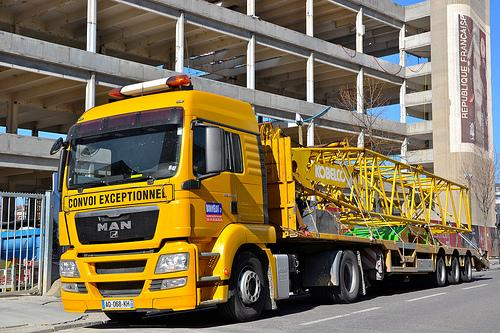Can you tell me about the central object featured in this image? A large yellow truck is parked on the side of the road, with various details such as a front license plate, windshield, side mirror, and safety lights clearly visible. Are there any structures nearby the truck? Describe what you see. Yes, there is a large sign hanging on the side of a building and a metal gate nearby the truck. Can you see any typography or graphics on the truck? Describe them. Yes, there is white text on the side of the truck, a blue and red sticker on the door, and black letters on the front. What is the state of the tree in the image? There is a leafless tree in the image. How many wheels are visible on the driver's side of the truck? Two wheels are visible on the driver's side of the truck. What does the sky look like in this image? The sky in this image is clear and blue, with no clouds present. Please name some details present on the front of the truck. The front of the truck features a windshield, headlights, a front grill, a front license plate, and the word "man" on the front of the bus. What can be observed on the road in the image? There are white lines painted on the road and a white line painted along the street. What is the overall sentiment of the image? The overall sentiment of the image is neutral, as it depicts an everyday scene of a truck parked on the side of a road. Please identify any additional objects that interact with the truck. There are grey metal stairs on the side of the truck and a large metal side mirror on the truck as well. Does the truck have a license plate? Yes, the truck has a license plate on the front. How many wheels can be seen on the driver's side of the truck? There are six visible wheels on the driver's side. Describe the logo on the front of the truck. The logo is a small rectangular shape with white text on the front grill. Identify the different materials found on the truck and its attachments. Metal (stairs, side mirror, and hubcap), glass (windshield), and rubber (tires). Describe any road markings that appear within the image. There are white lines painted on the road. Identify the bench located next to the leafless tree, and tell me what material it's made of. No, it's not mentioned in the image. Select the correct statement about the truck's front. B) It has a license plate and a windshield. Identify the presence of any formal advertising or branding within the image. There is an advertisement on the side of the building and branding on the truck. Create a short, imaginative story based on the scene shown in the image. Under a vast azure sky, a massive yellow beast paused by the road, tired from carrying dreams across cities. Its colorful tattoos and metal steps whispered of innumerable adventures, as it rested beneath the watchful gaze of a leafless tree. What color is the truck in the image? Yellow What natural elements are featured in the scene that can indicate the setting, environment, or season? A clear blue sky and a leafless tree. What is the most eye-catching element in the scene? The large yellow truck parked on the side of the road. Provide a brief description of what the truck driver might be doing based on the static state of the truck. The truck driver could be taking a break, resting during a long journey, or waiting for further instructions. In a poetic way, describe the scene shown in the image. A bold yellow beast rests by the road, its metal skin reflecting a clear blue sky, while guarding secrets within its mighty form. List down the objects related to the truck that are meant to be helpful for the driver. Windshield, sideview mirrors, headlights, and safety lights on the cab. Does the truck have any stickers on it? If yes, what are the colors? Yes, it has a blue and red sticker on the door. Identify and describe the textual content visible on the truck. There is white text on the side of the truck, the word "man" on the front, black letters on the front, and a logo on the grill. Using an informative tone, briefly describe the primary subject of the image. The image prominently features a large yellow truck parked on the side of a road, equipped with various structural and functional elements. Summarize the key elements of the scene, including the truck, its surroundings, and any unique features. Large yellow truck parked by the road, with a license plate, windshield, headlights, stickers, and metal steps; building with advertisement; leafless tree; clear blue sky. 